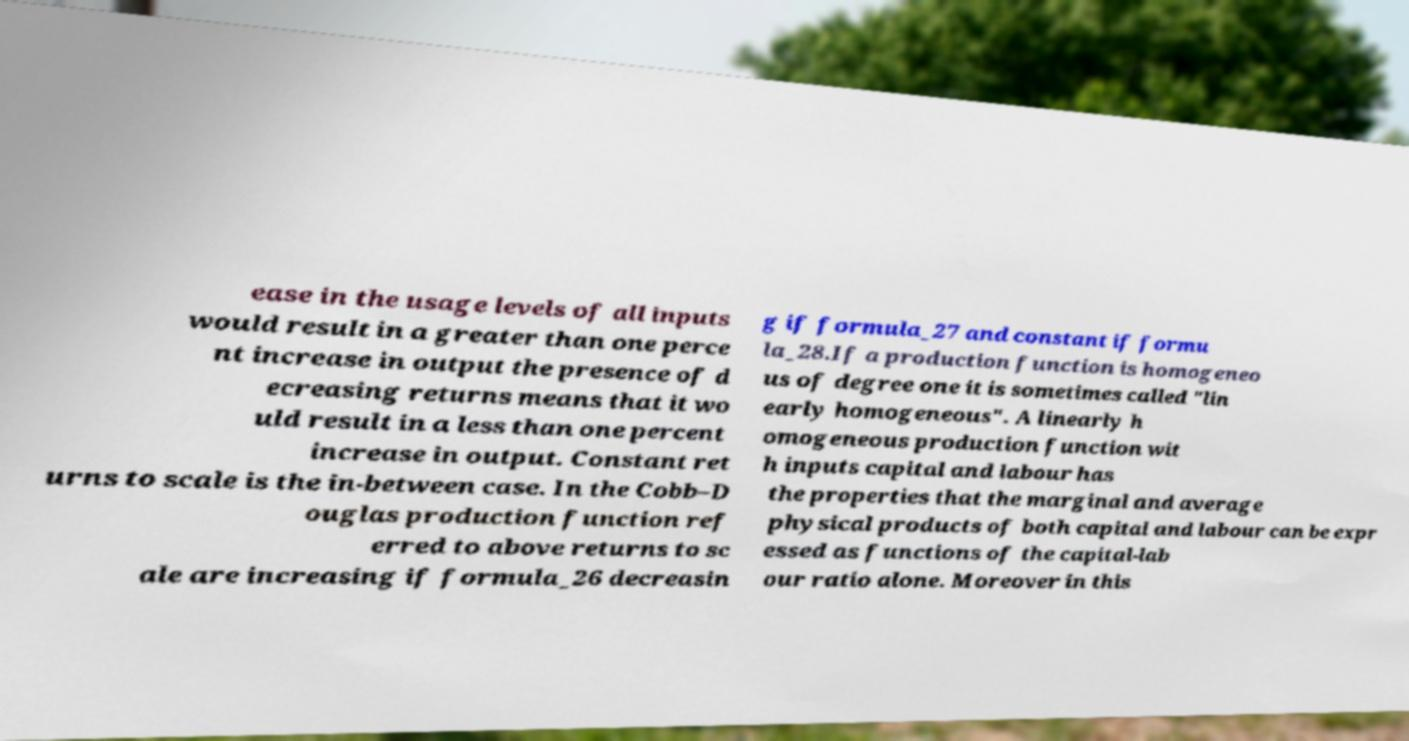Can you accurately transcribe the text from the provided image for me? ease in the usage levels of all inputs would result in a greater than one perce nt increase in output the presence of d ecreasing returns means that it wo uld result in a less than one percent increase in output. Constant ret urns to scale is the in-between case. In the Cobb–D ouglas production function ref erred to above returns to sc ale are increasing if formula_26 decreasin g if formula_27 and constant if formu la_28.If a production function is homogeneo us of degree one it is sometimes called "lin early homogeneous". A linearly h omogeneous production function wit h inputs capital and labour has the properties that the marginal and average physical products of both capital and labour can be expr essed as functions of the capital-lab our ratio alone. Moreover in this 